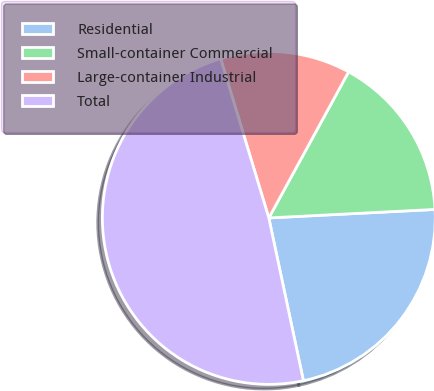Convert chart. <chart><loc_0><loc_0><loc_500><loc_500><pie_chart><fcel>Residential<fcel>Small-container Commercial<fcel>Large-container Industrial<fcel>Total<nl><fcel>22.48%<fcel>16.23%<fcel>12.63%<fcel>48.66%<nl></chart> 